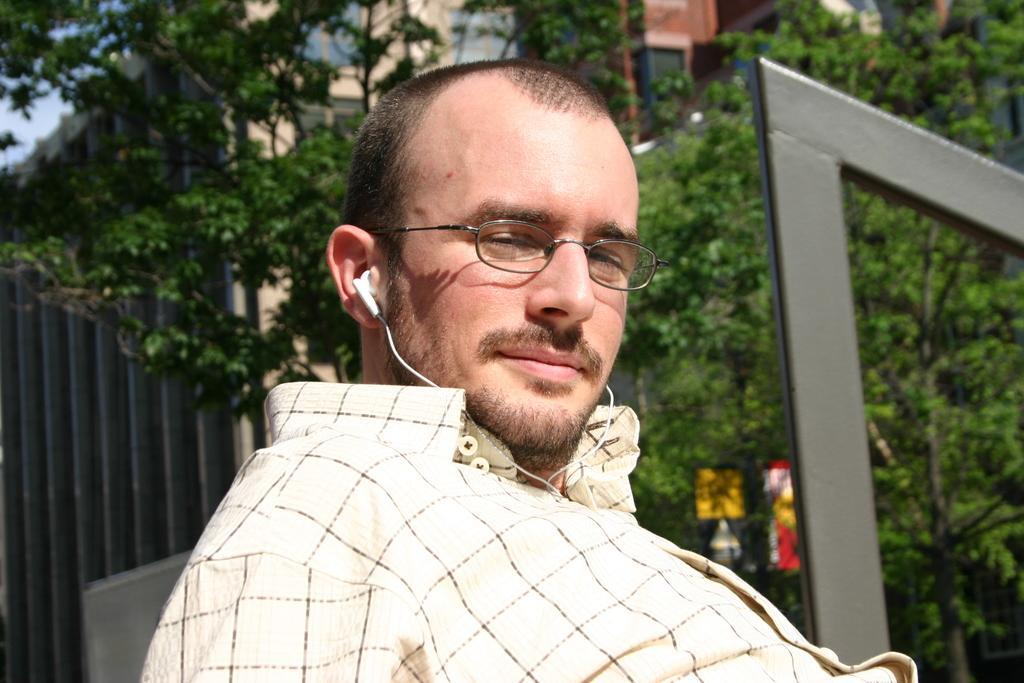Describe this image in one or two sentences. In this picture there is a man in the center of the image and there are buildings and trees in the background area of the image. 